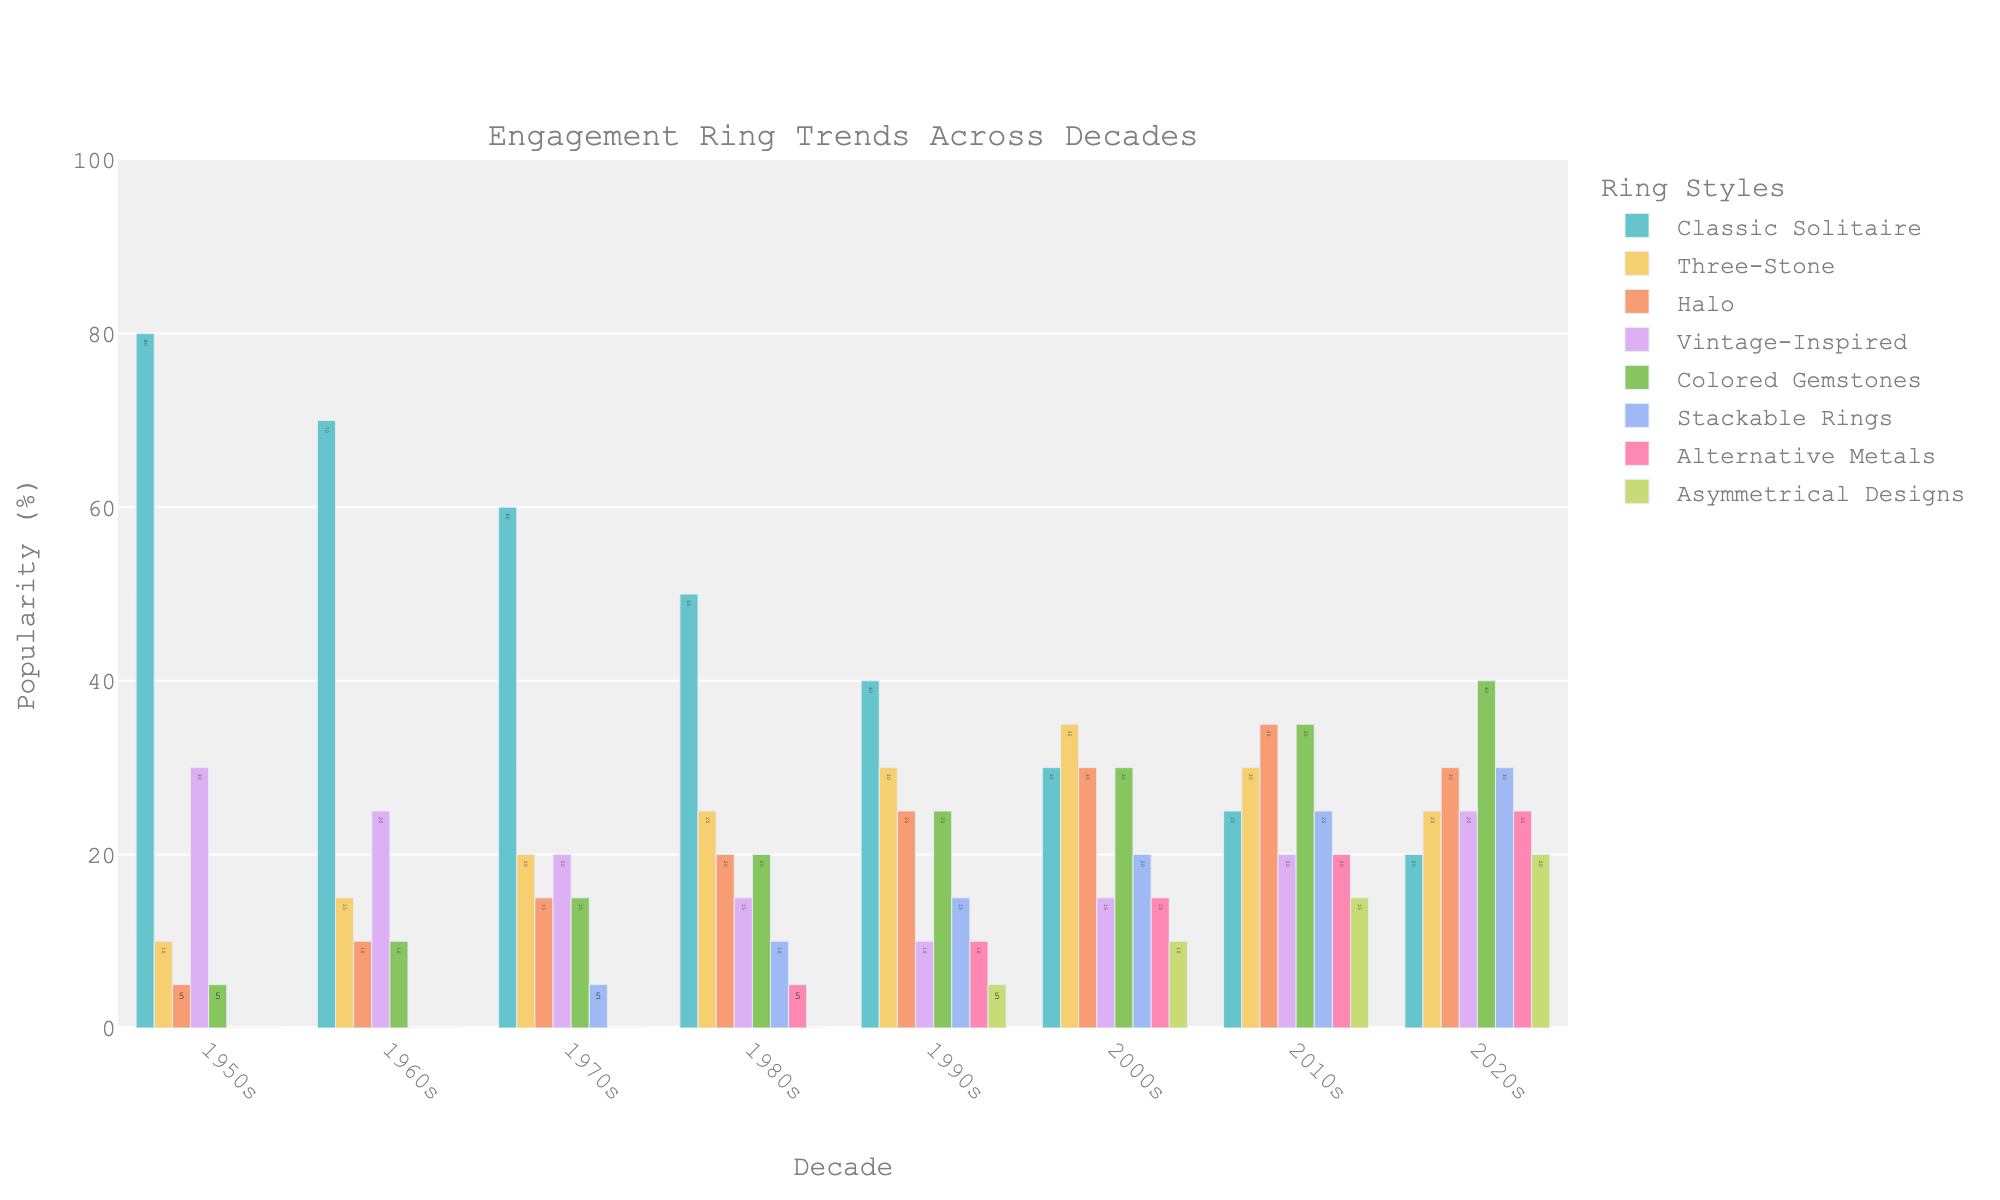Which decade had the highest popularity for classic solitaire engagement rings? To determine the decade with the highest popularity for classic solitaire rings, look at the bar heights for each decade under the "Classic Solitaire" category. The 1950s has the highest bar at 80%.
Answer: 1950s What is the combined popularity of halo and vintage-inspired rings in the 2010s? Add the popularity percentages of halo (35%) and vintage-inspired (20%) rings for the 2010s. That is 35% + 20% = 55%.
Answer: 55% How did the popularity of three-stone rings change from the 1970s to the 2000s? Compare the heights of the bars for three-stone rings in the 1970s (20%) and the 2000s (35%). The popularity increased by 35% - 20% = 15%.
Answer: Increased by 15% Which ring style became more popular every decade from the 1950s to the 2020s? By examining the increasing trend bars for each decade, colored gemstones show a consistent increase in popularity from 5% in the 1950s to 40% in the 2020s.
Answer: Colored Gemstones Among alternative metals and stackable rings, which was more popular in the 1990s? Compare the bar heights for alternative metals (10%) and stackable rings (15%) in the 1990s. Stackable rings are higher.
Answer: Stackable rings In which decade was the popularity of asymmetrical designs first recorded? Look at when the bar for asymmetrical designs first appears. It shows in the 1990s with a 5% popularity.
Answer: 1990s What is the difference in popularity between vintage-inspired and classic solitaire rings in the 2020s? Subtract the popularity of vintage-inspired rings (25%) from classic solitaire rings (20%) in the 2020s. That is 25% - 20% = 5%.
Answer: 5% What is the average popularity of stackable rings from the 1980s to the 2020s? To find the average, sum the popularity percentages of stackable rings: (10% + 15% + 20% + 25% + 30%) = 100%, then divide by 5 decades. 100% / 5 = 20%.
Answer: 20% Which ring style had the biggest decrease in popularity from the 1950s to the 2010s? Compare the changes in the percentages for each ring style from the 1950s to the 2010s. Classic solitaire decreases from 80% to 25%, a change of 55%, which is the largest decrease among all categories.
Answer: Classic Solitaire Between the 1950s and the 2020s, how many ring styles appeared for the first time? Observe the bars that start from zero in the 1950s and appear later, including colored gemstones (1960s), stackable rings (1970s), alternative metals (1980s), and asymmetrical designs (1990s). Four ring styles appeared: colored gemstones, stackable rings, alternative metals, and asymmetrical designs.
Answer: 4 